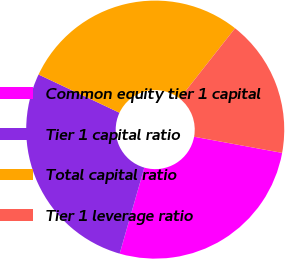Convert chart. <chart><loc_0><loc_0><loc_500><loc_500><pie_chart><fcel>Common equity tier 1 capital<fcel>Tier 1 capital ratio<fcel>Total capital ratio<fcel>Tier 1 leverage ratio<nl><fcel>26.56%<fcel>27.58%<fcel>28.6%<fcel>17.27%<nl></chart> 